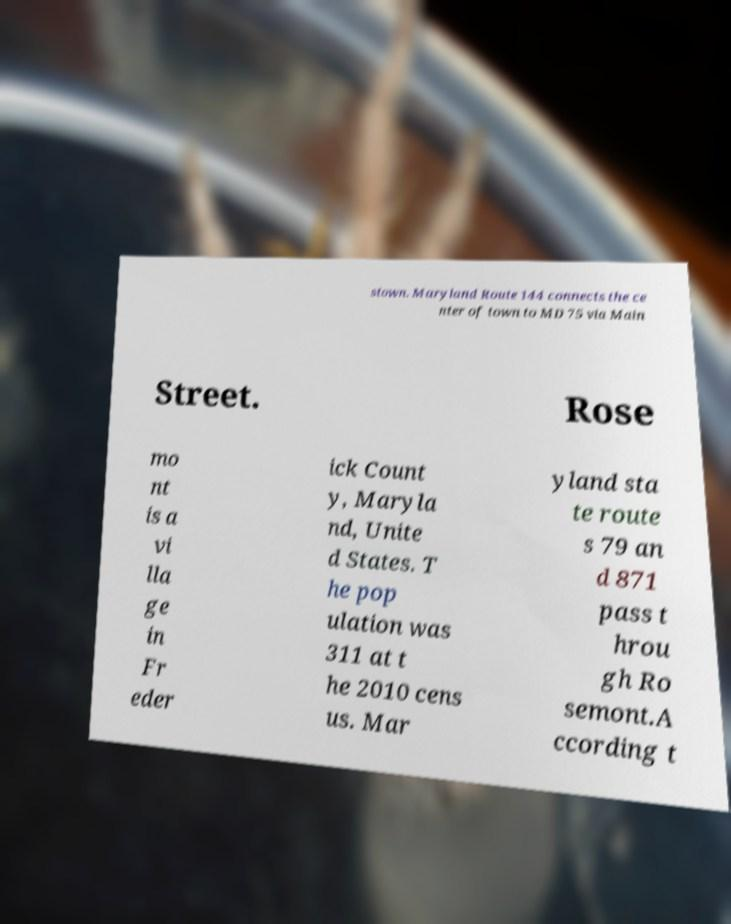Could you extract and type out the text from this image? stown. Maryland Route 144 connects the ce nter of town to MD 75 via Main Street. Rose mo nt is a vi lla ge in Fr eder ick Count y, Maryla nd, Unite d States. T he pop ulation was 311 at t he 2010 cens us. Mar yland sta te route s 79 an d 871 pass t hrou gh Ro semont.A ccording t 